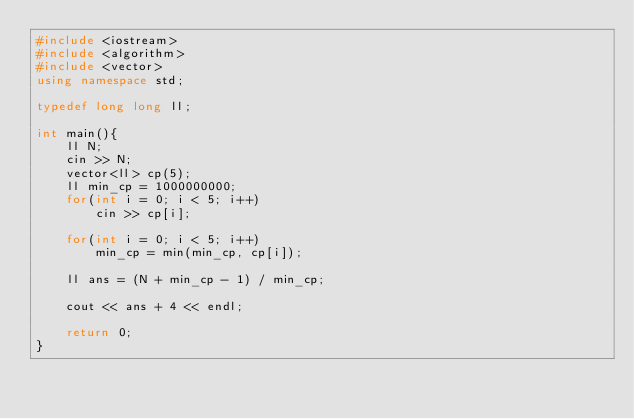<code> <loc_0><loc_0><loc_500><loc_500><_C++_>#include <iostream>
#include <algorithm>
#include <vector>
using namespace std;

typedef long long ll;

int main(){
    ll N;
    cin >> N;
    vector<ll> cp(5);
    ll min_cp = 1000000000;
    for(int i = 0; i < 5; i++)
        cin >> cp[i];

    for(int i = 0; i < 5; i++)
        min_cp = min(min_cp, cp[i]);
    
    ll ans = (N + min_cp - 1) / min_cp;

    cout << ans + 4 << endl;

    return 0;
}</code> 